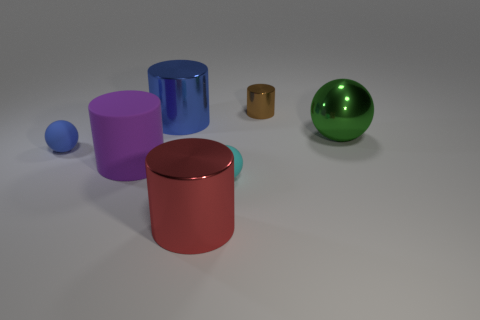What colors are the cylinders in the image? In the image, there are cylinders in three colors: red, purple, and blue. 